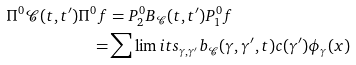Convert formula to latex. <formula><loc_0><loc_0><loc_500><loc_500>\Pi ^ { 0 } \mathcal { C } ( t , t ^ { \prime } ) \Pi ^ { 0 } f & = P ^ { 0 } _ { 2 } B _ { \mathcal { C } } ( t , t ^ { \prime } ) P _ { 1 } ^ { 0 } f \\ = & \sum \lim i t s _ { \gamma , \gamma ^ { \prime } } b _ { \mathcal { C } } ( \gamma , \gamma ^ { \prime } , t ) c ( \gamma ^ { \prime } ) \phi _ { \gamma } ( x )</formula> 